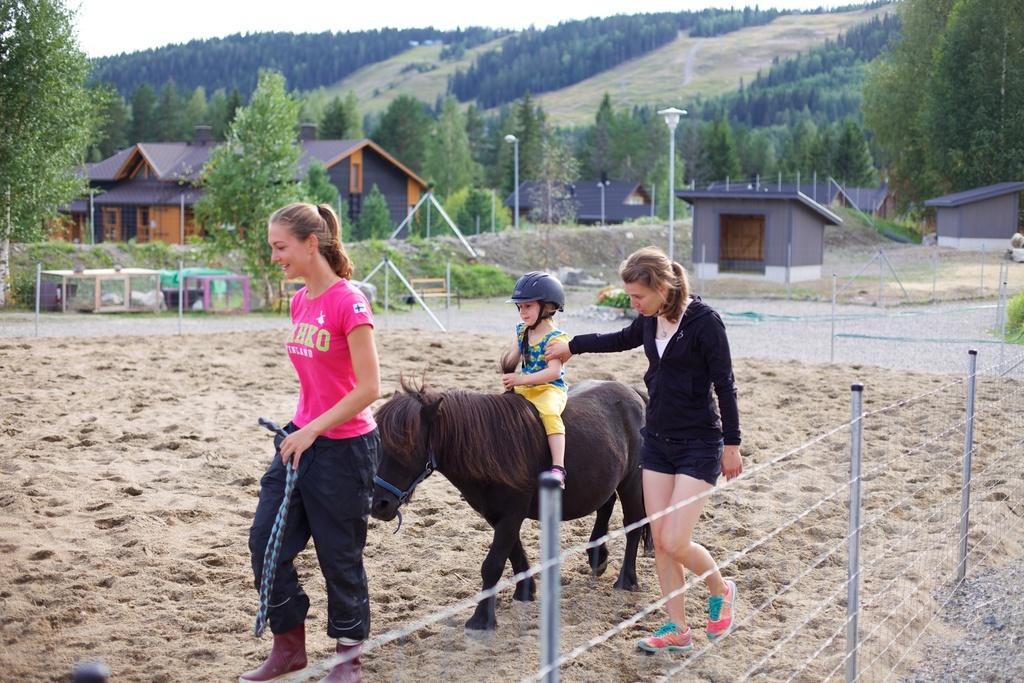How many women are present in the image? There are two women in the image. What are the women doing in the image? The women are walking on the floor. What is the kid doing in the image? The kid is riding a horse on the floor. What can be seen in the background of the image? There are houses, trees, and a mountain in the background of the image. What type of apparel is the iron wearing in the image? There is no iron present in the image, and therefore no apparel can be associated with it. 